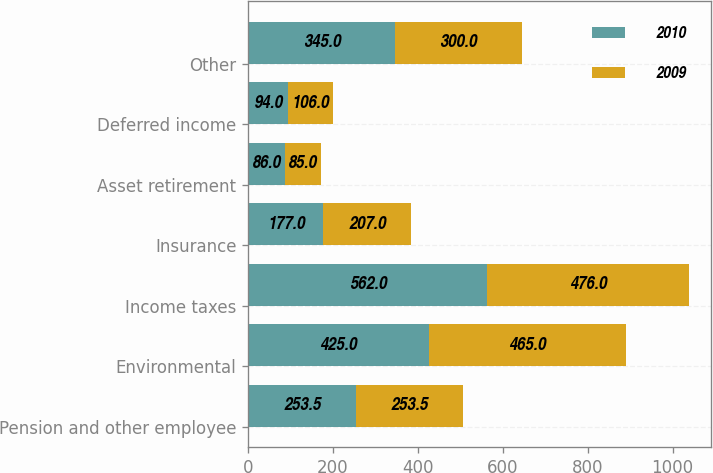<chart> <loc_0><loc_0><loc_500><loc_500><stacked_bar_chart><ecel><fcel>Pension and other employee<fcel>Environmental<fcel>Income taxes<fcel>Insurance<fcel>Asset retirement<fcel>Deferred income<fcel>Other<nl><fcel>2010<fcel>253.5<fcel>425<fcel>562<fcel>177<fcel>86<fcel>94<fcel>345<nl><fcel>2009<fcel>253.5<fcel>465<fcel>476<fcel>207<fcel>85<fcel>106<fcel>300<nl></chart> 